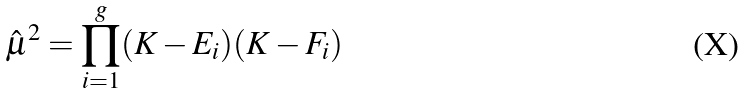Convert formula to latex. <formula><loc_0><loc_0><loc_500><loc_500>\hat { \mu } ^ { 2 } = \prod _ { i = 1 } ^ { g } ( K - E _ { i } ) ( K - F _ { i } )</formula> 